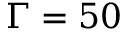<formula> <loc_0><loc_0><loc_500><loc_500>\Gamma = 5 0</formula> 